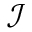Convert formula to latex. <formula><loc_0><loc_0><loc_500><loc_500>\mathcal { I }</formula> 